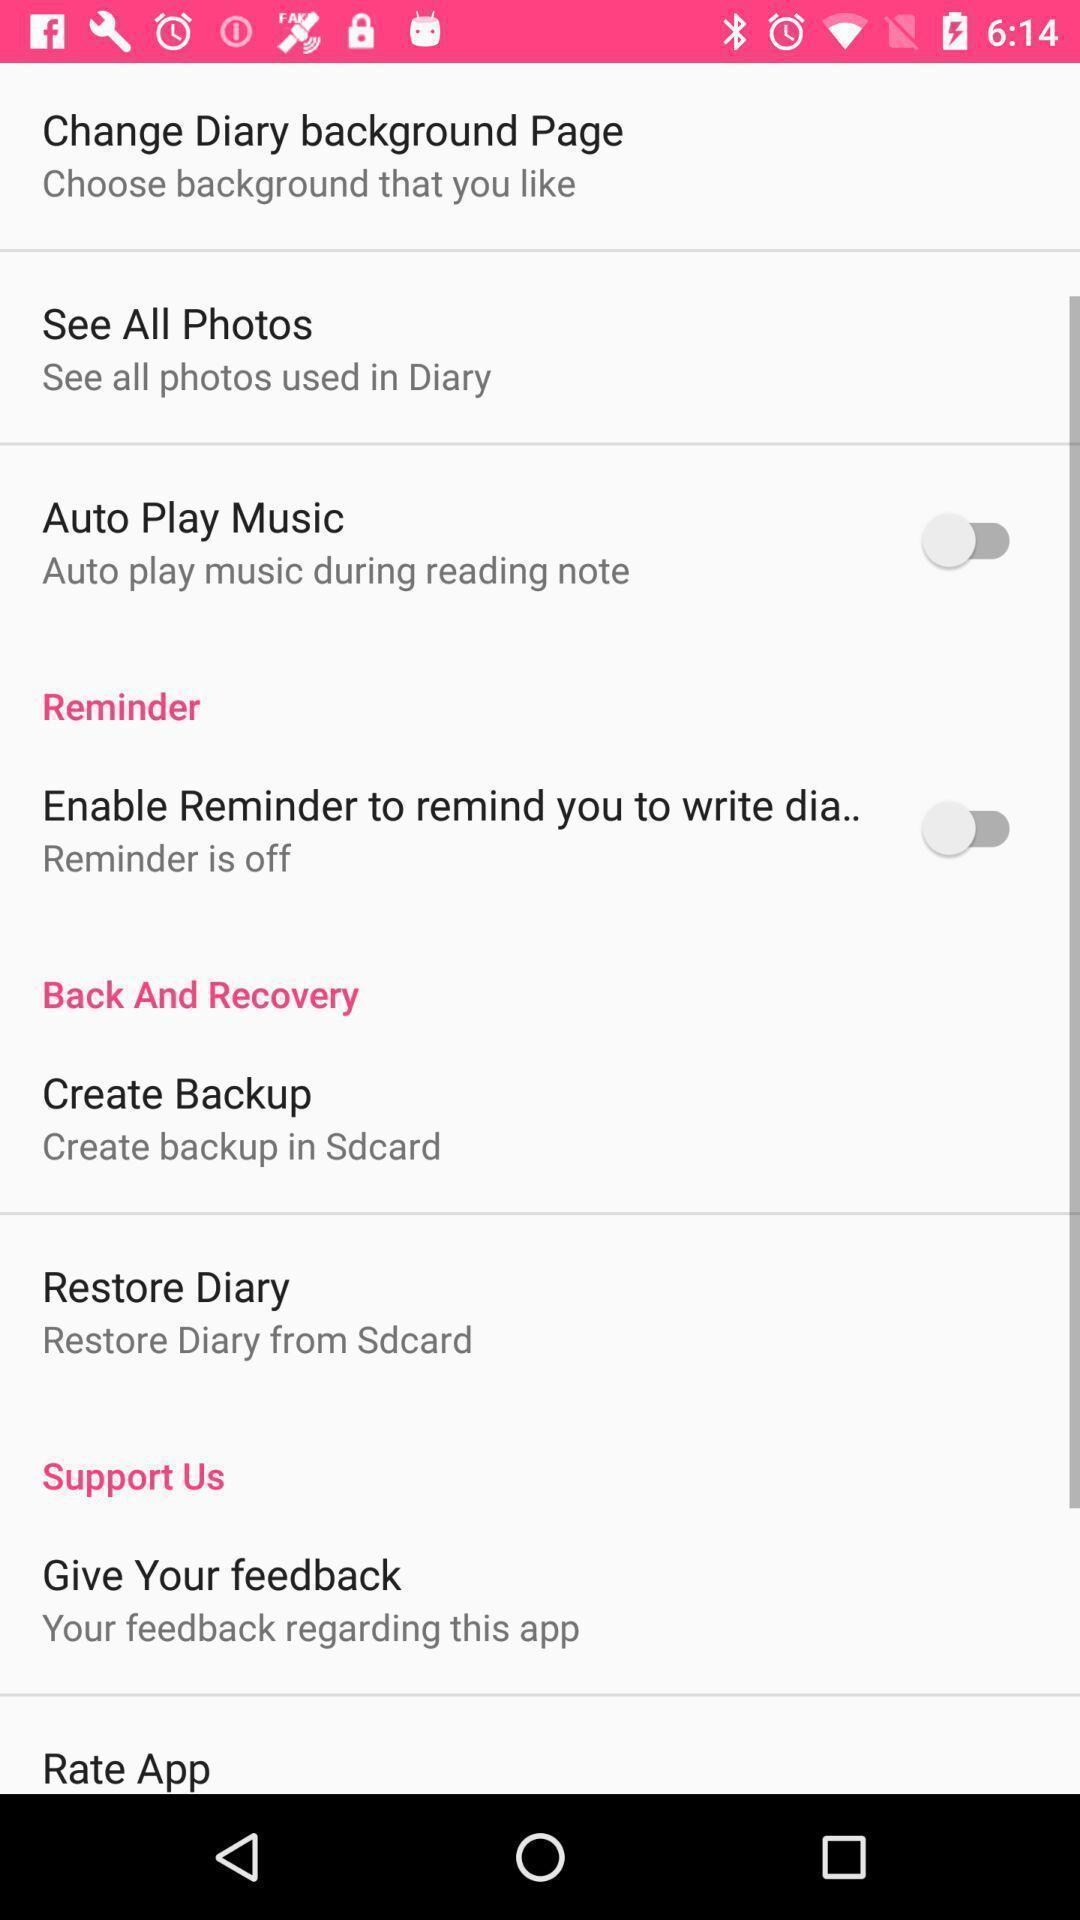What can you discern from this picture? Settings page. 